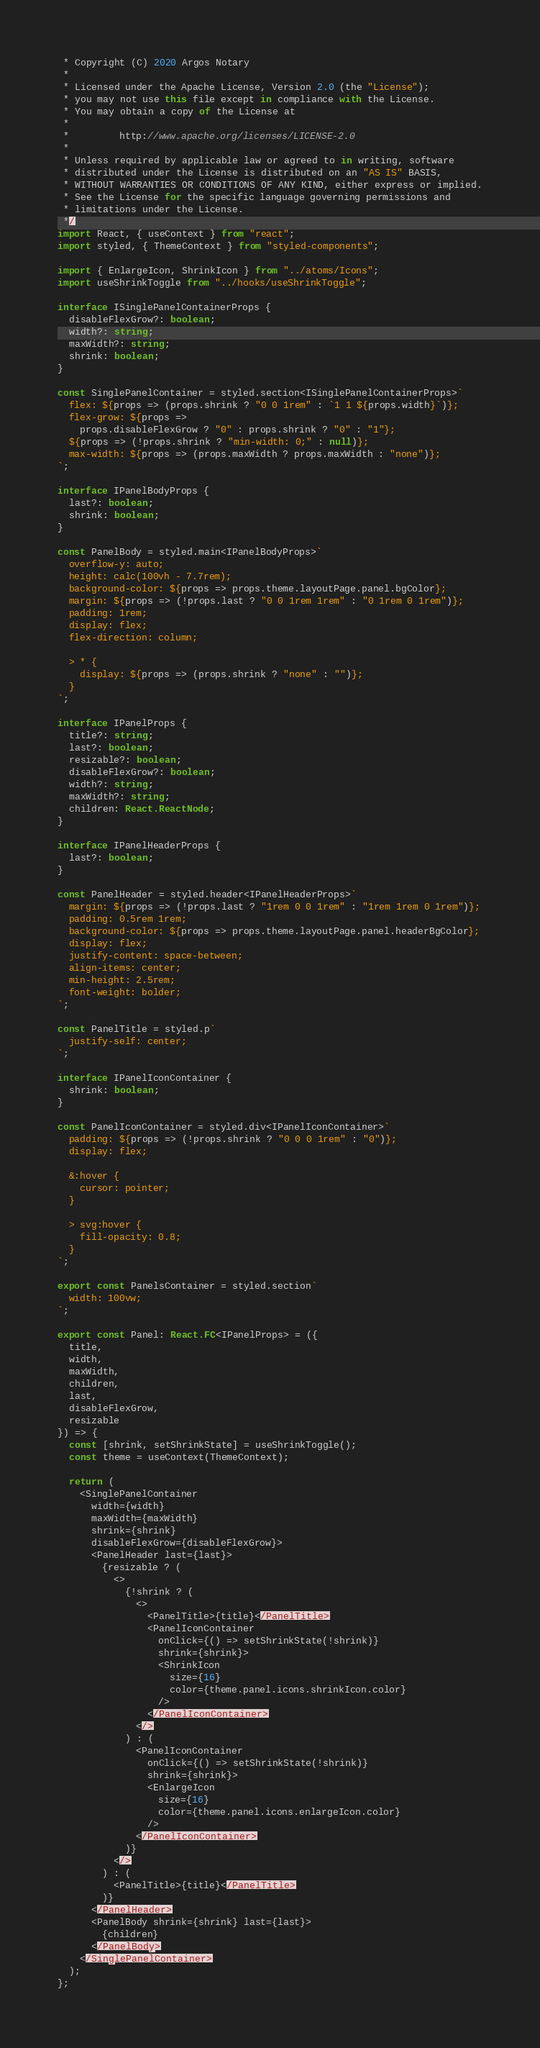<code> <loc_0><loc_0><loc_500><loc_500><_TypeScript_> * Copyright (C) 2020 Argos Notary
 *
 * Licensed under the Apache License, Version 2.0 (the "License");
 * you may not use this file except in compliance with the License.
 * You may obtain a copy of the License at
 *
 *         http://www.apache.org/licenses/LICENSE-2.0
 *
 * Unless required by applicable law or agreed to in writing, software
 * distributed under the License is distributed on an "AS IS" BASIS,
 * WITHOUT WARRANTIES OR CONDITIONS OF ANY KIND, either express or implied.
 * See the License for the specific language governing permissions and
 * limitations under the License.
 */
import React, { useContext } from "react";
import styled, { ThemeContext } from "styled-components";

import { EnlargeIcon, ShrinkIcon } from "../atoms/Icons";
import useShrinkToggle from "../hooks/useShrinkToggle";

interface ISinglePanelContainerProps {
  disableFlexGrow?: boolean;
  width?: string;
  maxWidth?: string;
  shrink: boolean;
}

const SinglePanelContainer = styled.section<ISinglePanelContainerProps>`
  flex: ${props => (props.shrink ? "0 0 1rem" : `1 1 ${props.width}`)};
  flex-grow: ${props =>
    props.disableFlexGrow ? "0" : props.shrink ? "0" : "1"};
  ${props => (!props.shrink ? "min-width: 0;" : null)};
  max-width: ${props => (props.maxWidth ? props.maxWidth : "none")};
`;

interface IPanelBodyProps {
  last?: boolean;
  shrink: boolean;
}

const PanelBody = styled.main<IPanelBodyProps>`
  overflow-y: auto;
  height: calc(100vh - 7.7rem);
  background-color: ${props => props.theme.layoutPage.panel.bgColor};
  margin: ${props => (!props.last ? "0 0 1rem 1rem" : "0 1rem 0 1rem")};
  padding: 1rem;
  display: flex;
  flex-direction: column;

  > * {
    display: ${props => (props.shrink ? "none" : "")};
  }
`;

interface IPanelProps {
  title?: string;
  last?: boolean;
  resizable?: boolean;
  disableFlexGrow?: boolean;
  width?: string;
  maxWidth?: string;
  children: React.ReactNode;
}

interface IPanelHeaderProps {
  last?: boolean;
}

const PanelHeader = styled.header<IPanelHeaderProps>`
  margin: ${props => (!props.last ? "1rem 0 0 1rem" : "1rem 1rem 0 1rem")};
  padding: 0.5rem 1rem;
  background-color: ${props => props.theme.layoutPage.panel.headerBgColor};
  display: flex;
  justify-content: space-between;
  align-items: center;
  min-height: 2.5rem;
  font-weight: bolder;
`;

const PanelTitle = styled.p`
  justify-self: center;
`;

interface IPanelIconContainer {
  shrink: boolean;
}

const PanelIconContainer = styled.div<IPanelIconContainer>`
  padding: ${props => (!props.shrink ? "0 0 0 1rem" : "0")};
  display: flex;

  &:hover {
    cursor: pointer;
  }

  > svg:hover {
    fill-opacity: 0.8;
  }
`;

export const PanelsContainer = styled.section`
  width: 100vw;
`;

export const Panel: React.FC<IPanelProps> = ({
  title,
  width,
  maxWidth,
  children,
  last,
  disableFlexGrow,
  resizable
}) => {
  const [shrink, setShrinkState] = useShrinkToggle();
  const theme = useContext(ThemeContext);

  return (
    <SinglePanelContainer
      width={width}
      maxWidth={maxWidth}
      shrink={shrink}
      disableFlexGrow={disableFlexGrow}>
      <PanelHeader last={last}>
        {resizable ? (
          <>
            {!shrink ? (
              <>
                <PanelTitle>{title}</PanelTitle>
                <PanelIconContainer
                  onClick={() => setShrinkState(!shrink)}
                  shrink={shrink}>
                  <ShrinkIcon
                    size={16}
                    color={theme.panel.icons.shrinkIcon.color}
                  />
                </PanelIconContainer>
              </>
            ) : (
              <PanelIconContainer
                onClick={() => setShrinkState(!shrink)}
                shrink={shrink}>
                <EnlargeIcon
                  size={16}
                  color={theme.panel.icons.enlargeIcon.color}
                />
              </PanelIconContainer>
            )}
          </>
        ) : (
          <PanelTitle>{title}</PanelTitle>
        )}
      </PanelHeader>
      <PanelBody shrink={shrink} last={last}>
        {children}
      </PanelBody>
    </SinglePanelContainer>
  );
};
</code> 